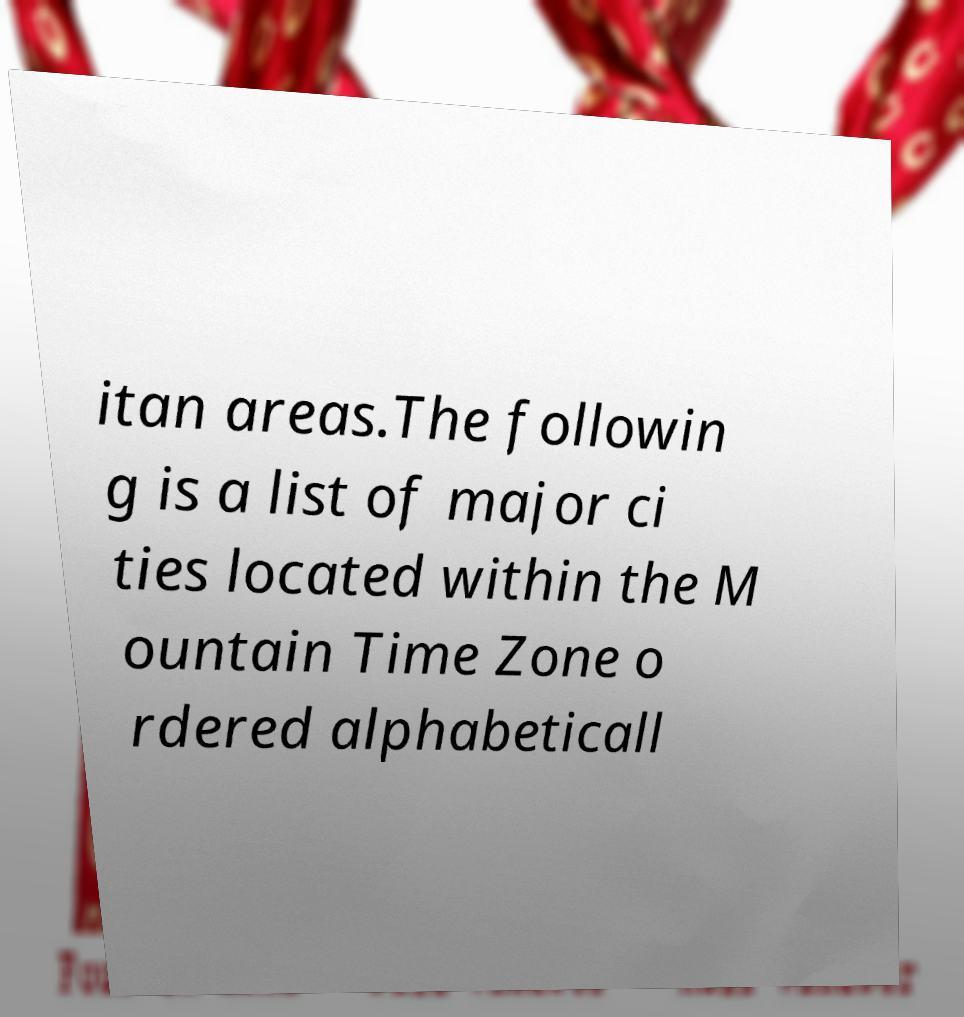Could you assist in decoding the text presented in this image and type it out clearly? itan areas.The followin g is a list of major ci ties located within the M ountain Time Zone o rdered alphabeticall 